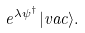Convert formula to latex. <formula><loc_0><loc_0><loc_500><loc_500>e ^ { \lambda \psi ^ { \dagger } } | v a c \rangle .</formula> 